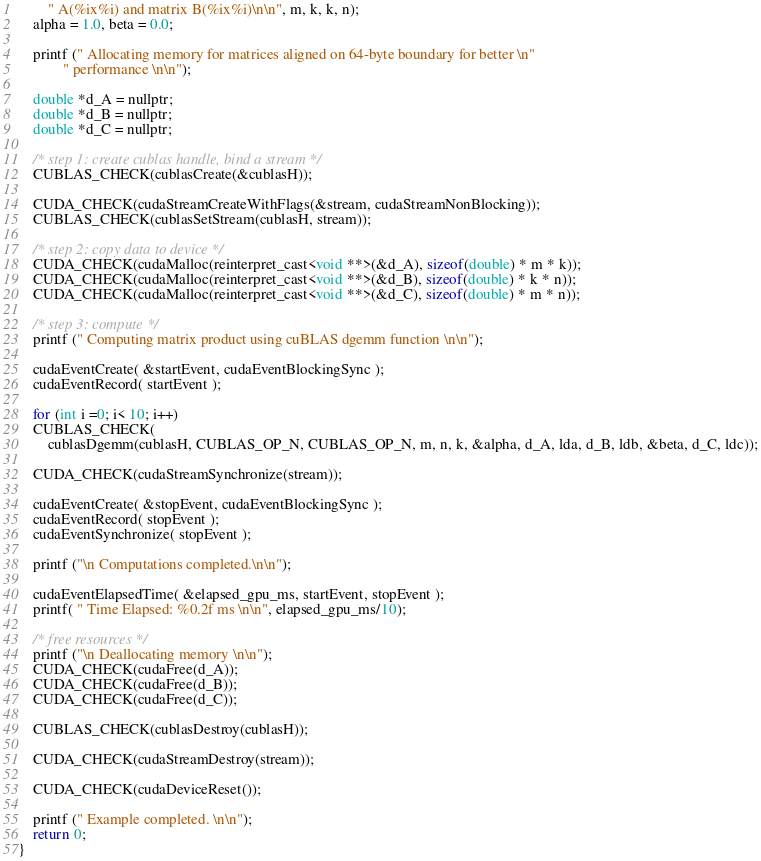<code> <loc_0><loc_0><loc_500><loc_500><_Cuda_>        " A(%ix%i) and matrix B(%ix%i)\n\n", m, k, k, n);
    alpha = 1.0, beta = 0.0;

    printf (" Allocating memory for matrices aligned on 64-byte boundary for better \n"
            " performance \n\n");

    double *d_A = nullptr;
    double *d_B = nullptr;
    double *d_C = nullptr;

    /* step 1: create cublas handle, bind a stream */
    CUBLAS_CHECK(cublasCreate(&cublasH));

    CUDA_CHECK(cudaStreamCreateWithFlags(&stream, cudaStreamNonBlocking));
    CUBLAS_CHECK(cublasSetStream(cublasH, stream));

    /* step 2: copy data to device */
    CUDA_CHECK(cudaMalloc(reinterpret_cast<void **>(&d_A), sizeof(double) * m * k));
    CUDA_CHECK(cudaMalloc(reinterpret_cast<void **>(&d_B), sizeof(double) * k * n));
    CUDA_CHECK(cudaMalloc(reinterpret_cast<void **>(&d_C), sizeof(double) * m * n));

    /* step 3: compute */
    printf (" Computing matrix product using cuBLAS dgemm function \n\n");

    cudaEventCreate( &startEvent, cudaEventBlockingSync );
    cudaEventRecord( startEvent );

    for (int i =0; i< 10; i++)
    CUBLAS_CHECK(
        cublasDgemm(cublasH, CUBLAS_OP_N, CUBLAS_OP_N, m, n, k, &alpha, d_A, lda, d_B, ldb, &beta, d_C, ldc));

    CUDA_CHECK(cudaStreamSynchronize(stream));

    cudaEventCreate( &stopEvent, cudaEventBlockingSync );
    cudaEventRecord( stopEvent );
    cudaEventSynchronize( stopEvent );

    printf ("\n Computations completed.\n\n");

    cudaEventElapsedTime( &elapsed_gpu_ms, startEvent, stopEvent );
    printf( " Time Elapsed: %0.2f ms \n\n", elapsed_gpu_ms/10);

    /* free resources */
    printf ("\n Deallocating memory \n\n");
    CUDA_CHECK(cudaFree(d_A));
    CUDA_CHECK(cudaFree(d_B));
    CUDA_CHECK(cudaFree(d_C));

    CUBLAS_CHECK(cublasDestroy(cublasH));

    CUDA_CHECK(cudaStreamDestroy(stream));

    CUDA_CHECK(cudaDeviceReset());

    printf (" Example completed. \n\n");
    return 0;
}
</code> 